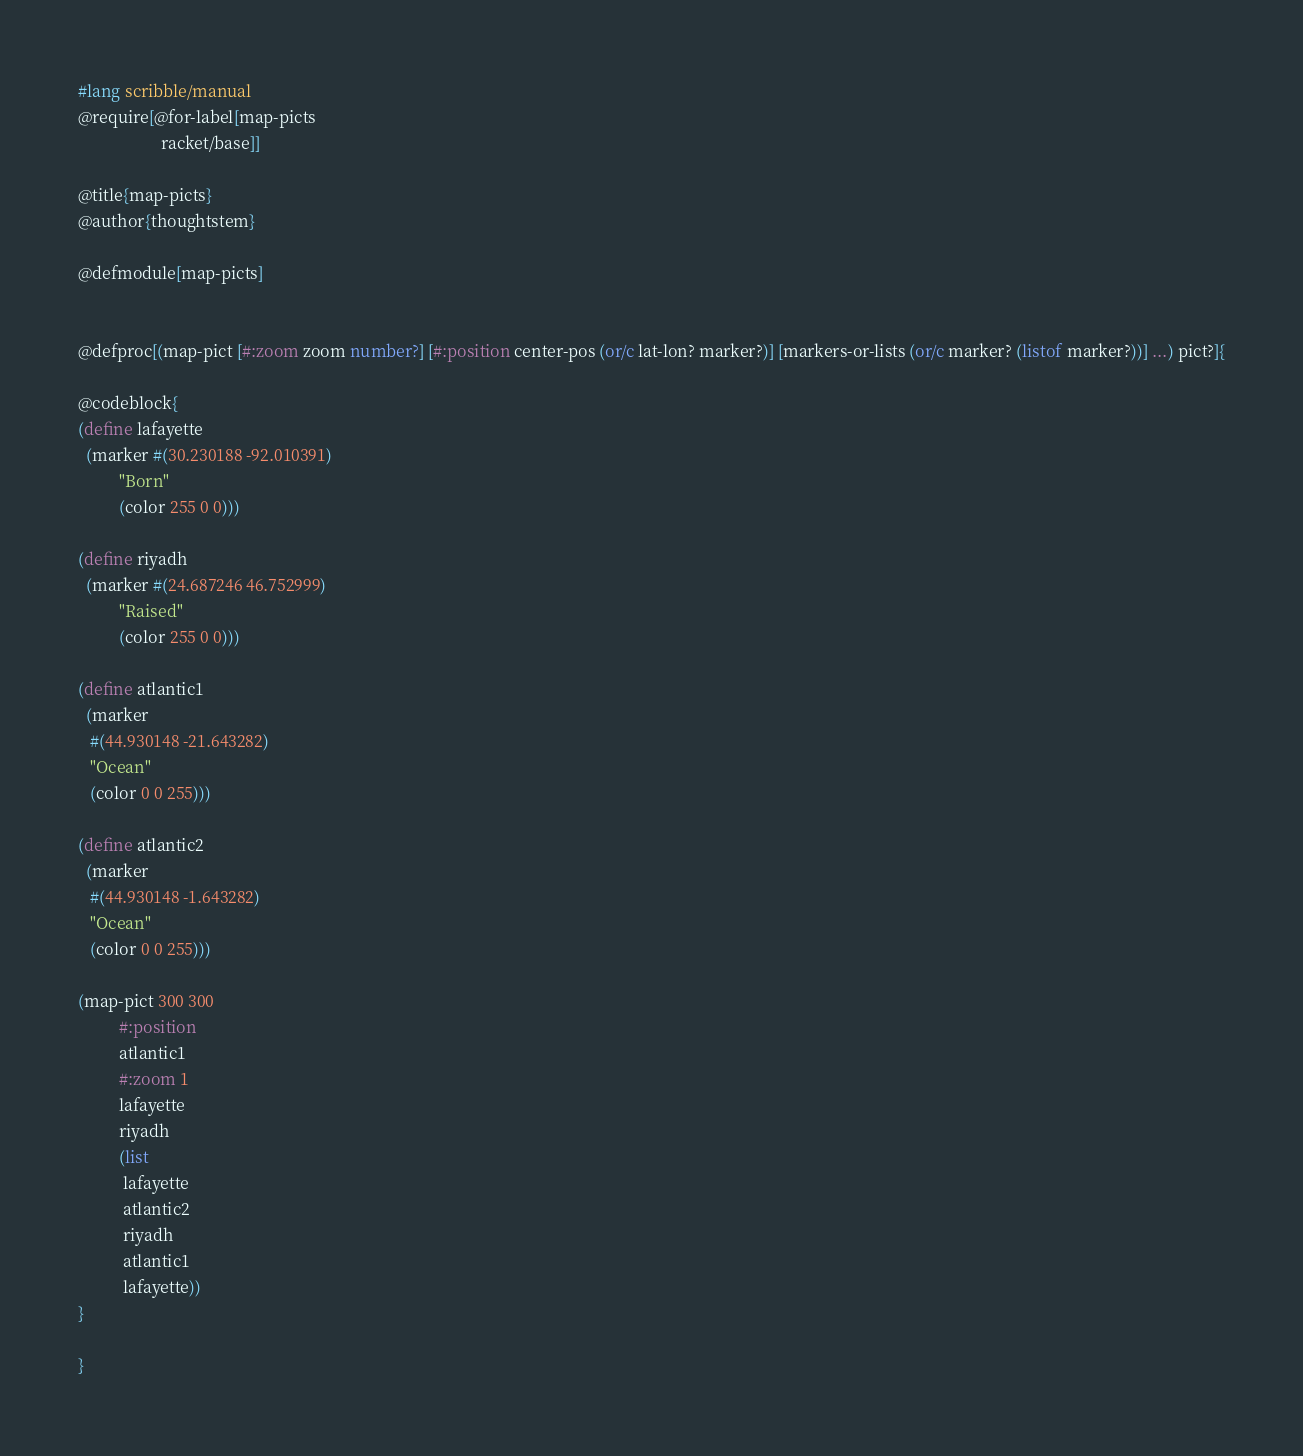<code> <loc_0><loc_0><loc_500><loc_500><_Racket_>#lang scribble/manual
@require[@for-label[map-picts
                    racket/base]]

@title{map-picts}
@author{thoughtstem}

@defmodule[map-picts]


@defproc[(map-pict [#:zoom zoom number?] [#:position center-pos (or/c lat-lon? marker?)] [markers-or-lists (or/c marker? (listof marker?))] ...) pict?]{

@codeblock{
(define lafayette
  (marker #(30.230188 -92.010391) 
          "Born"
          (color 255 0 0)))

(define riyadh
  (marker #(24.687246 46.752999) 
          "Raised"
          (color 255 0 0)))

(define atlantic1
  (marker
   #(44.930148 -21.643282)
   "Ocean"
   (color 0 0 255)))

(define atlantic2
  (marker
   #(44.930148 -1.643282)
   "Ocean"
   (color 0 0 255)))

(map-pict 300 300
          #:position
          atlantic1
          #:zoom 1
          lafayette
          riyadh
          (list
           lafayette
           atlantic2
           riyadh
           atlantic1
           lafayette))
}

}
</code> 